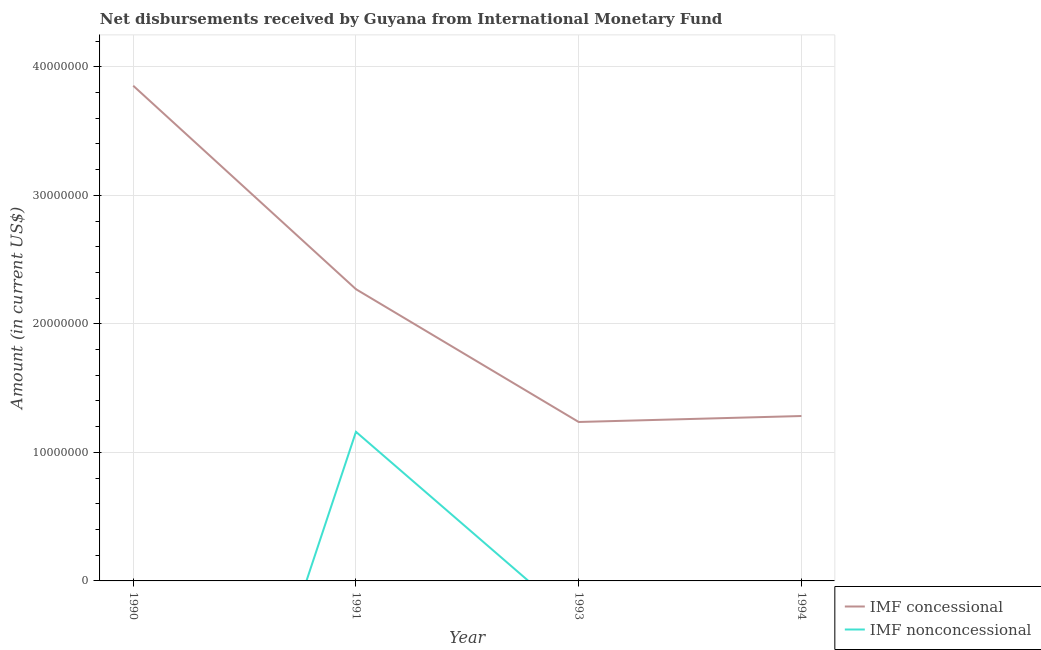How many different coloured lines are there?
Keep it short and to the point. 2. Does the line corresponding to net non concessional disbursements from imf intersect with the line corresponding to net concessional disbursements from imf?
Your answer should be very brief. No. Is the number of lines equal to the number of legend labels?
Give a very brief answer. No. What is the net non concessional disbursements from imf in 1991?
Your answer should be very brief. 1.16e+07. Across all years, what is the maximum net non concessional disbursements from imf?
Your answer should be very brief. 1.16e+07. What is the total net non concessional disbursements from imf in the graph?
Provide a succinct answer. 1.16e+07. What is the difference between the net concessional disbursements from imf in 1991 and that in 1994?
Provide a succinct answer. 9.87e+06. What is the difference between the net concessional disbursements from imf in 1994 and the net non concessional disbursements from imf in 1990?
Keep it short and to the point. 1.28e+07. What is the average net concessional disbursements from imf per year?
Give a very brief answer. 2.16e+07. In the year 1991, what is the difference between the net concessional disbursements from imf and net non concessional disbursements from imf?
Offer a very short reply. 1.11e+07. What is the ratio of the net concessional disbursements from imf in 1991 to that in 1994?
Provide a short and direct response. 1.77. Is the net concessional disbursements from imf in 1993 less than that in 1994?
Give a very brief answer. Yes. What is the difference between the highest and the second highest net concessional disbursements from imf?
Give a very brief answer. 1.58e+07. What is the difference between the highest and the lowest net concessional disbursements from imf?
Provide a short and direct response. 2.62e+07. Is the net concessional disbursements from imf strictly greater than the net non concessional disbursements from imf over the years?
Provide a short and direct response. Yes. Is the net non concessional disbursements from imf strictly less than the net concessional disbursements from imf over the years?
Offer a terse response. Yes. How many lines are there?
Provide a succinct answer. 2. What is the difference between two consecutive major ticks on the Y-axis?
Ensure brevity in your answer.  1.00e+07. Are the values on the major ticks of Y-axis written in scientific E-notation?
Provide a succinct answer. No. How many legend labels are there?
Offer a terse response. 2. How are the legend labels stacked?
Make the answer very short. Vertical. What is the title of the graph?
Your answer should be very brief. Net disbursements received by Guyana from International Monetary Fund. Does "International Visitors" appear as one of the legend labels in the graph?
Your response must be concise. No. What is the Amount (in current US$) in IMF concessional in 1990?
Offer a terse response. 3.85e+07. What is the Amount (in current US$) in IMF concessional in 1991?
Your answer should be very brief. 2.27e+07. What is the Amount (in current US$) in IMF nonconcessional in 1991?
Your answer should be compact. 1.16e+07. What is the Amount (in current US$) in IMF concessional in 1993?
Your response must be concise. 1.24e+07. What is the Amount (in current US$) in IMF concessional in 1994?
Offer a terse response. 1.28e+07. What is the Amount (in current US$) in IMF nonconcessional in 1994?
Offer a terse response. 0. Across all years, what is the maximum Amount (in current US$) of IMF concessional?
Offer a very short reply. 3.85e+07. Across all years, what is the maximum Amount (in current US$) of IMF nonconcessional?
Ensure brevity in your answer.  1.16e+07. Across all years, what is the minimum Amount (in current US$) in IMF concessional?
Make the answer very short. 1.24e+07. What is the total Amount (in current US$) in IMF concessional in the graph?
Keep it short and to the point. 8.64e+07. What is the total Amount (in current US$) of IMF nonconcessional in the graph?
Provide a succinct answer. 1.16e+07. What is the difference between the Amount (in current US$) of IMF concessional in 1990 and that in 1991?
Make the answer very short. 1.58e+07. What is the difference between the Amount (in current US$) of IMF concessional in 1990 and that in 1993?
Provide a short and direct response. 2.62e+07. What is the difference between the Amount (in current US$) of IMF concessional in 1990 and that in 1994?
Give a very brief answer. 2.57e+07. What is the difference between the Amount (in current US$) of IMF concessional in 1991 and that in 1993?
Your answer should be compact. 1.03e+07. What is the difference between the Amount (in current US$) of IMF concessional in 1991 and that in 1994?
Ensure brevity in your answer.  9.87e+06. What is the difference between the Amount (in current US$) in IMF concessional in 1993 and that in 1994?
Give a very brief answer. -4.65e+05. What is the difference between the Amount (in current US$) in IMF concessional in 1990 and the Amount (in current US$) in IMF nonconcessional in 1991?
Keep it short and to the point. 2.69e+07. What is the average Amount (in current US$) of IMF concessional per year?
Your answer should be very brief. 2.16e+07. What is the average Amount (in current US$) in IMF nonconcessional per year?
Ensure brevity in your answer.  2.90e+06. In the year 1991, what is the difference between the Amount (in current US$) of IMF concessional and Amount (in current US$) of IMF nonconcessional?
Your answer should be very brief. 1.11e+07. What is the ratio of the Amount (in current US$) in IMF concessional in 1990 to that in 1991?
Provide a succinct answer. 1.7. What is the ratio of the Amount (in current US$) in IMF concessional in 1990 to that in 1993?
Offer a terse response. 3.12. What is the ratio of the Amount (in current US$) of IMF concessional in 1990 to that in 1994?
Your answer should be compact. 3. What is the ratio of the Amount (in current US$) of IMF concessional in 1991 to that in 1993?
Provide a short and direct response. 1.84. What is the ratio of the Amount (in current US$) in IMF concessional in 1991 to that in 1994?
Your answer should be compact. 1.77. What is the ratio of the Amount (in current US$) in IMF concessional in 1993 to that in 1994?
Give a very brief answer. 0.96. What is the difference between the highest and the second highest Amount (in current US$) in IMF concessional?
Keep it short and to the point. 1.58e+07. What is the difference between the highest and the lowest Amount (in current US$) in IMF concessional?
Offer a terse response. 2.62e+07. What is the difference between the highest and the lowest Amount (in current US$) of IMF nonconcessional?
Offer a terse response. 1.16e+07. 